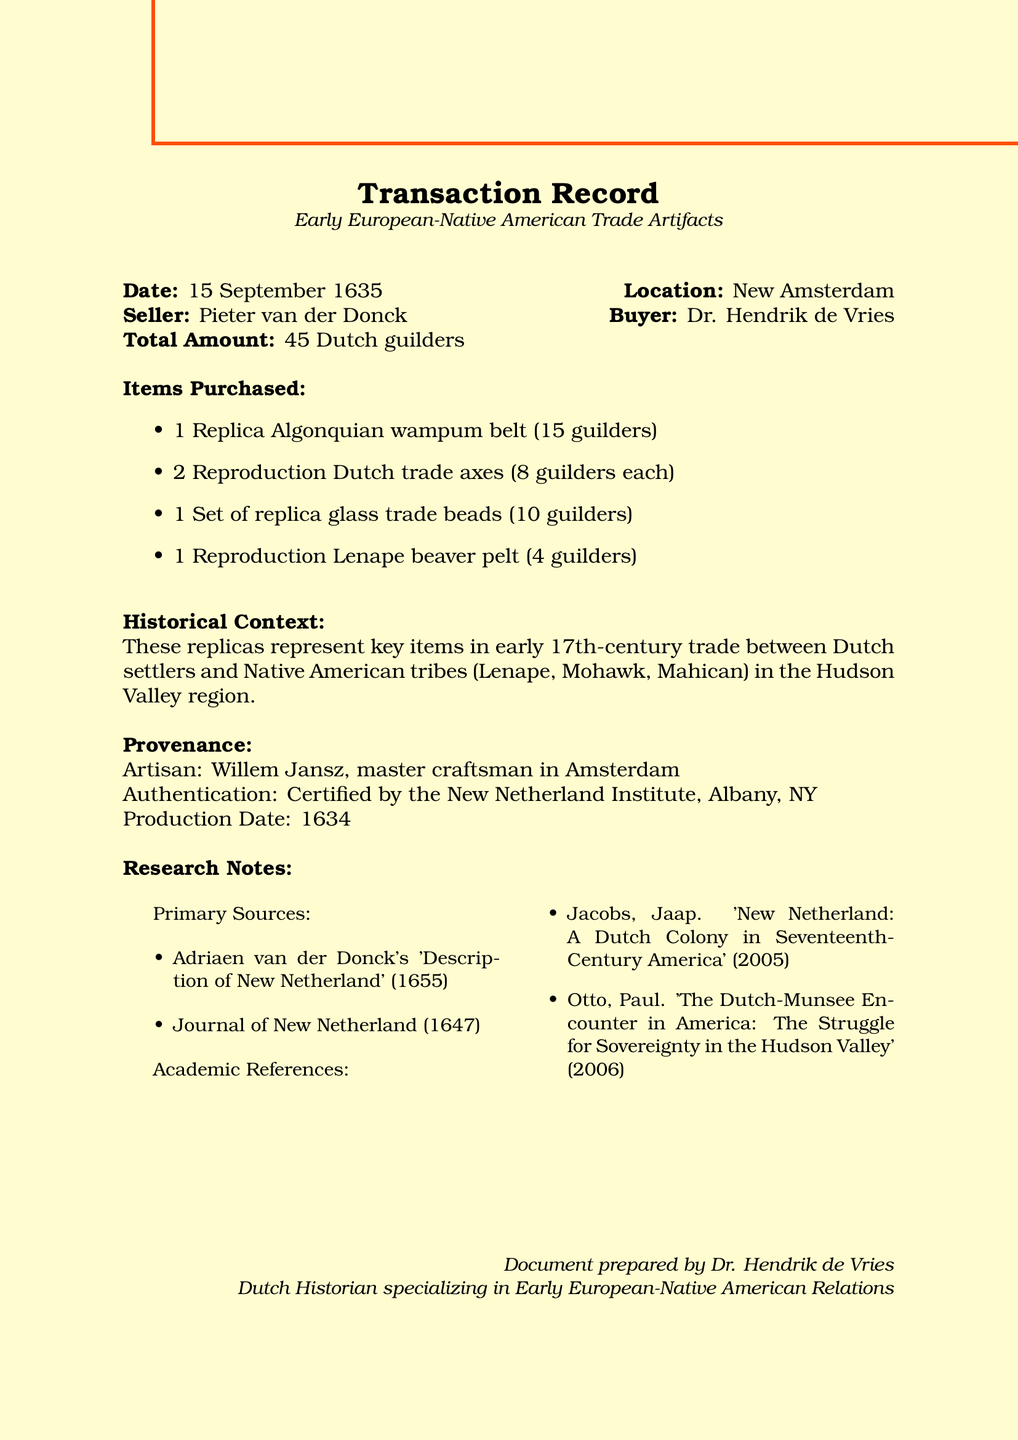What is the date of the transaction? The date of the transaction is explicitly mentioned in the document.
Answer: 15 September 1635 Who was the seller in this transaction? The seller's name is provided in the transaction details section.
Answer: Pieter van der Donck How many reproduction Dutch trade axes were purchased? The quantity of reproduction Dutch trade axes bought is stated in the list of items purchased.
Answer: 2 What is the total amount of the transaction? The total amount is clearly indicated in the transaction details section.
Answer: 45 Dutch guilders Which Native American tribes are mentioned in the historical context? The historical context section lists the Native American tribes involved in the trade.
Answer: Lenape, Mohawk, Mahican Who certified the artifacts? The document states that the artifacts were certified by an institute, which provides the authentication source.
Answer: New Netherland Institute What is the description of the replica Algonquian wampum belt? The description provides insight into the significance of the item in trade and diplomacy.
Answer: Reproduction of a 17th-century wampum belt, used in trade and diplomacy Who is the artisan responsible for the artifacts? The artisan responsible for crafting the artifacts is mentioned in the provenance section.
Answer: Willem Jansz What year were the artifacts produced? The production date of the artifacts is stated in the provenance section.
Answer: 1634 